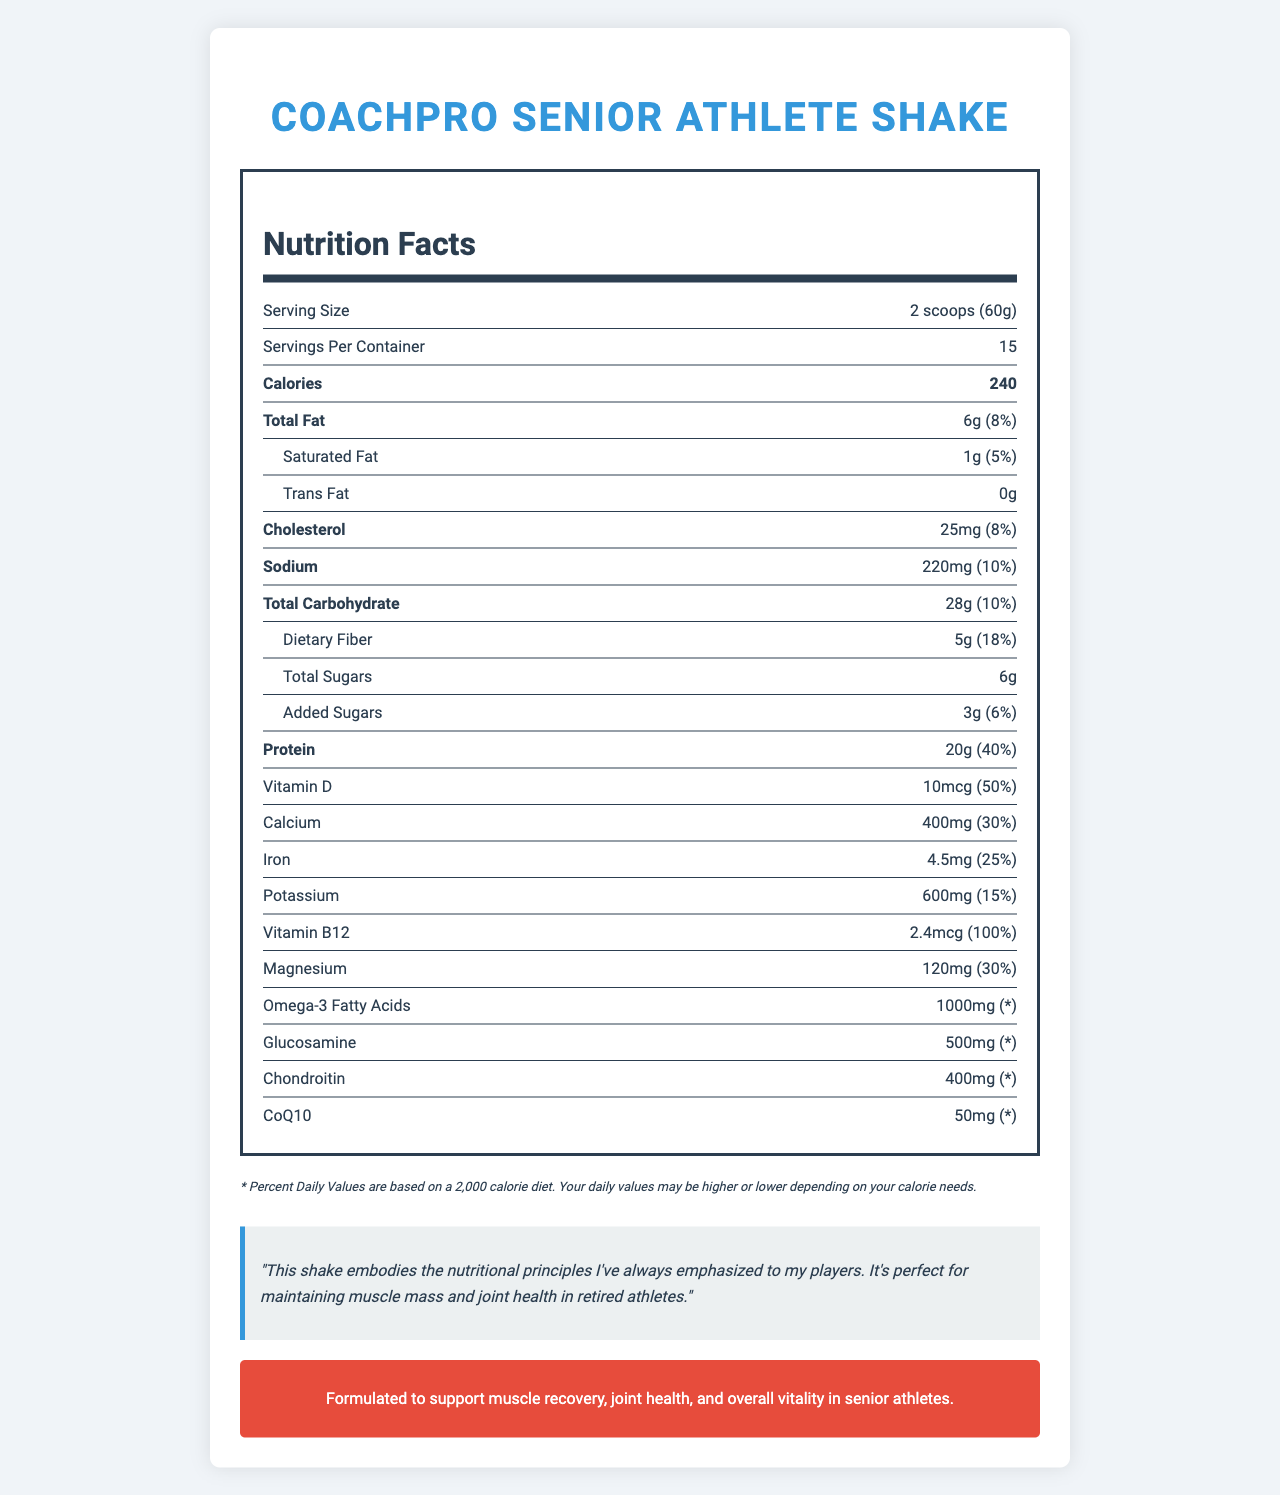What is the serving size of the CoachPro Senior Athlete Shake? The serving size is clearly listed as "2 scoops (60g)" in the nutrition facts section.
Answer: 2 scoops (60g) How many servings are there in each container? The document states that there are 15 servings per container.
Answer: 15 How many calories are in one serving of the shake? The number of calories per serving is listed as 240.
Answer: 240 How much protein is in a serving, and what percentage of the daily value does it provide? The document specifies that each serving contains 20g of protein, which is 40% of the daily value.
Answer: 20g, 40% What is the total amount of sugars in one serving? The total sugars per serving are listed as 6g, including 3g of added sugars.
Answer: 6g Is there any trans fat in the CoachPro Senior Athlete Shake? The nutrition facts label indicates 0g of trans fat.
Answer: No How much dietary fiber does one serving contain? Each serving provides 5g of dietary fiber, as stated in the nutrition facts.
Answer: 5g Which nutrient has the highest daily value percentage in a serving? A. Calcium B. Vitamin D C. Vitamin B12 D. Protein Vitamin B12 has the highest daily value percentage at 100% per serving.
Answer: C What is the percentage daily value of magnesium in the shake? A. 20% B. 25% C. 30% D. 35% The percentage daily value of magnesium is 30%.
Answer: C True or False: The shake contains both glucosamine and chondroitin. The nutrition facts section lists both glucosamine (500mg) and chondroitin (400mg).
Answer: True Summarize the main nutritional benefits of the CoachPro Senior Athlete Shake. The document emphasizes the nutritional aspects geared towards aging athletes, focusing on muscle recovery, joint health, and overall vitality. The shake's contents are tailored to support these functions through a blend of proteins, vitamins, minerals, and other essential compounds.
Answer: The CoachPro Senior Athlete Shake is designed to support senior athletes by providing a balanced mixture of protein, vitamins, and minerals. Each serving contains 20g of protein for muscle maintenance, essential vitamins like vitamin D and B12, and minerals such as calcium and potassium for bone and overall health. Additionally, it includes beneficial compounds like omega-3 fatty acids, glucosamine, and chondroitin to support joint health. Where is the fish oil sourced from? The document states that omega-3 fatty acids are from fish oil but does not specify the source of the fish oil.
Answer: Cannot be determined 